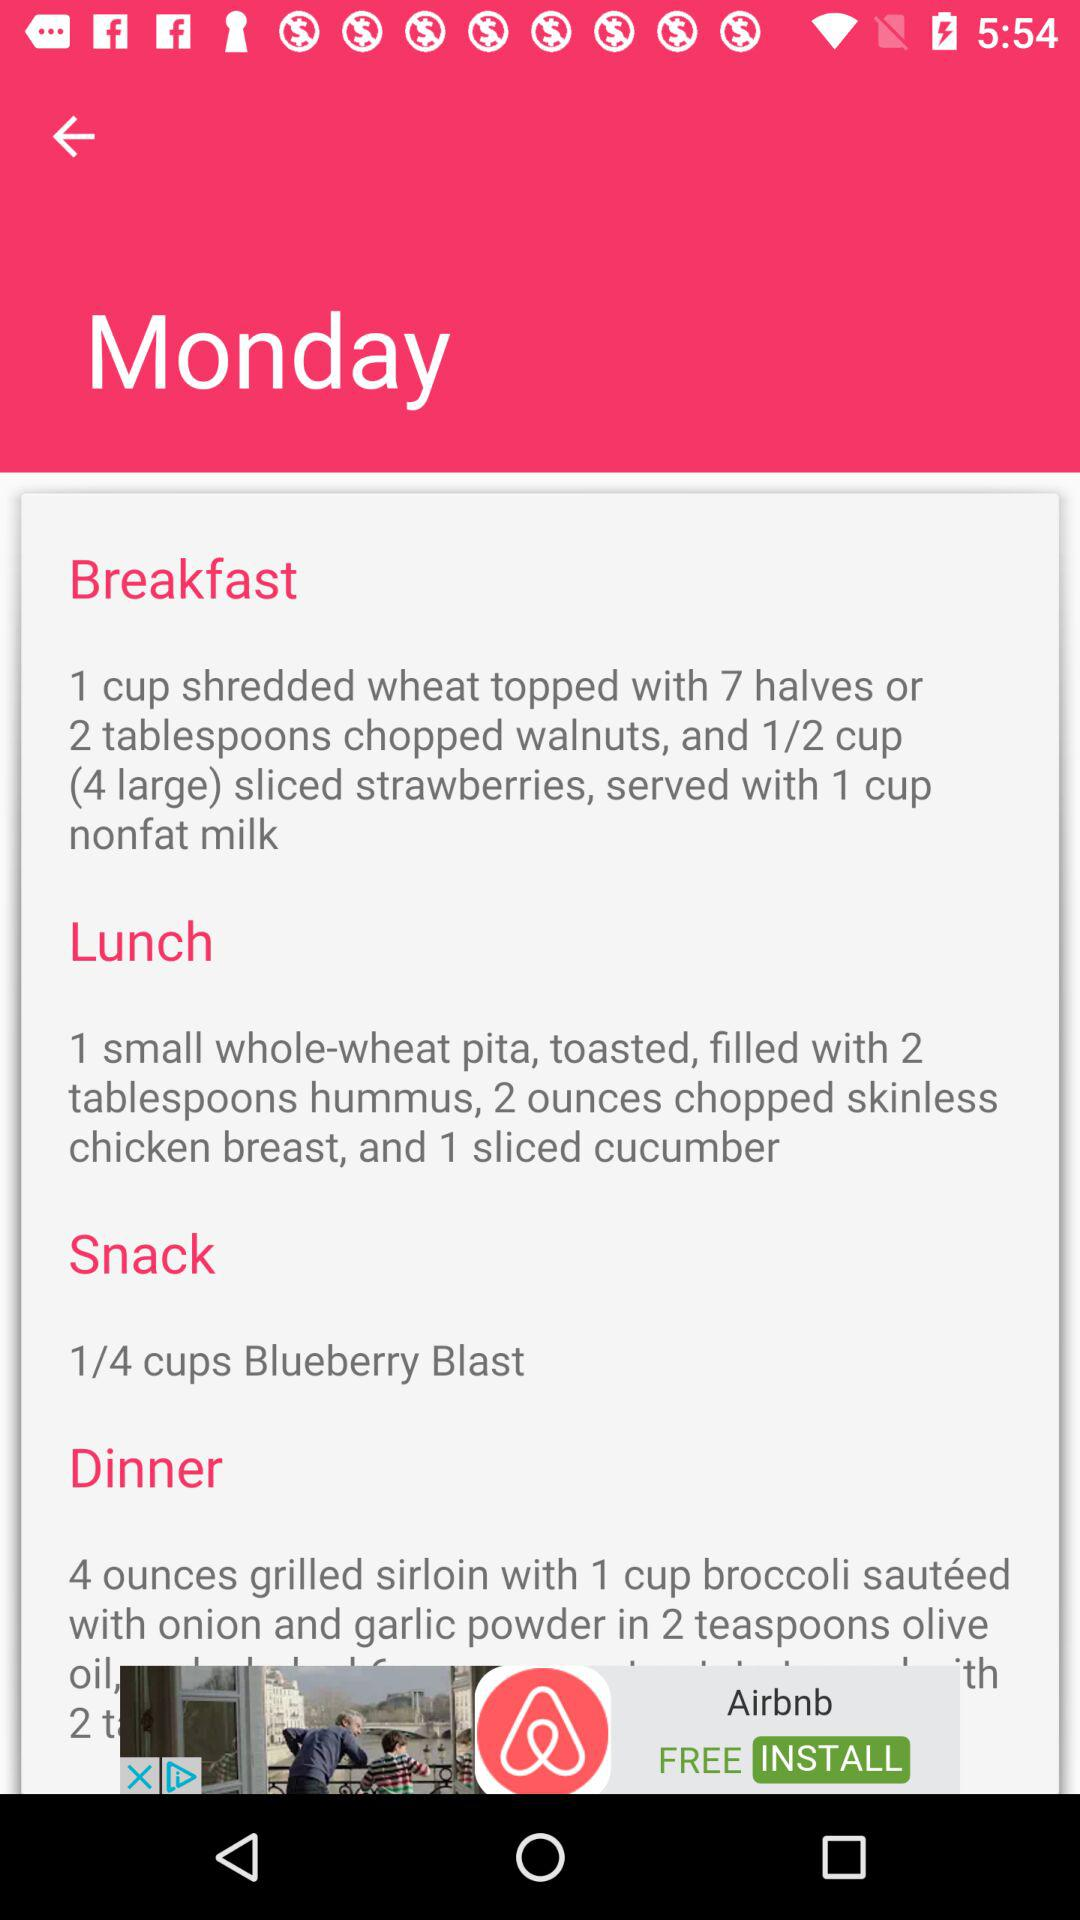How many more cups of milk are consumed for breakfast than for lunch?
Answer the question using a single word or phrase. 1 